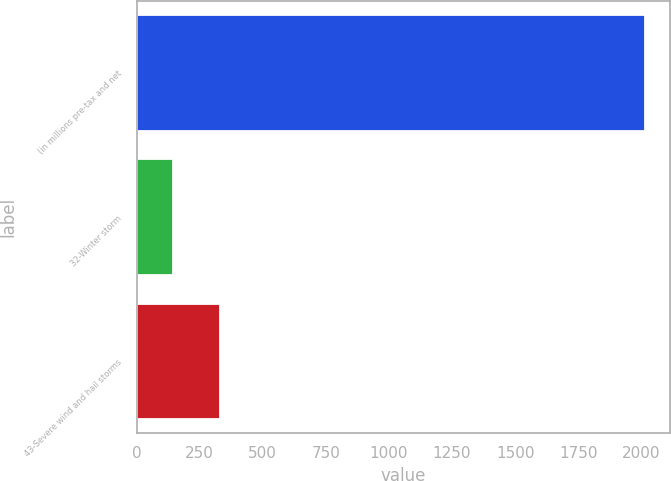<chart> <loc_0><loc_0><loc_500><loc_500><bar_chart><fcel>(in millions pre-tax and net<fcel>32-Winter storm<fcel>43-Severe wind and hail storms<nl><fcel>2014<fcel>144<fcel>331<nl></chart> 